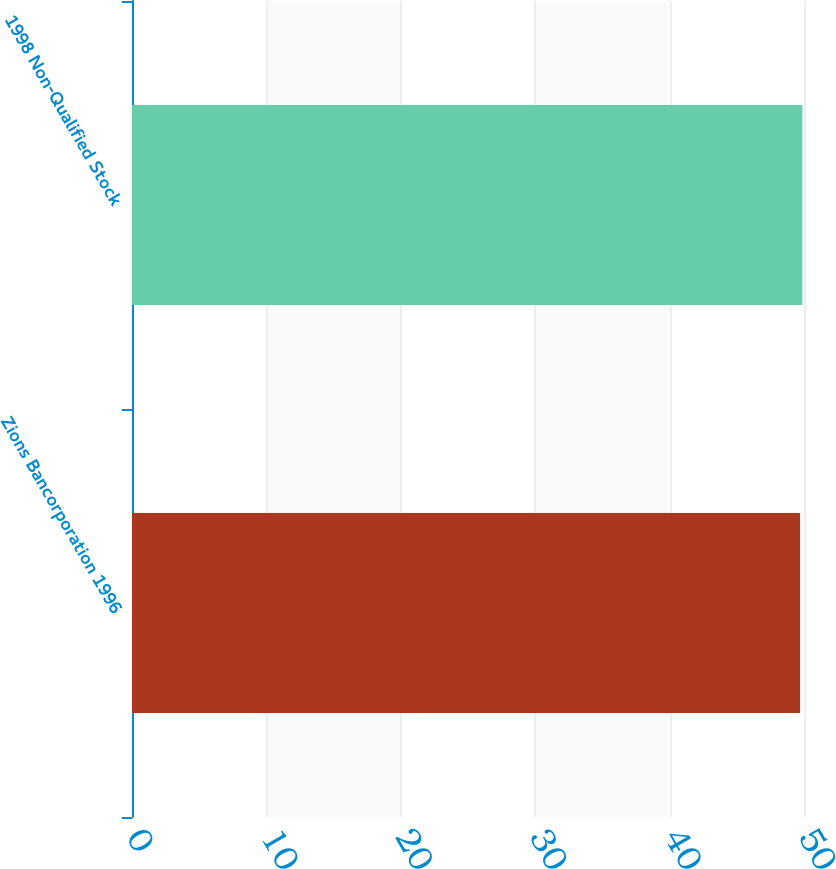Convert chart to OTSL. <chart><loc_0><loc_0><loc_500><loc_500><bar_chart><fcel>Zions Bancorporation 1996<fcel>1998 Non-Qualified Stock<nl><fcel>49.71<fcel>49.88<nl></chart> 